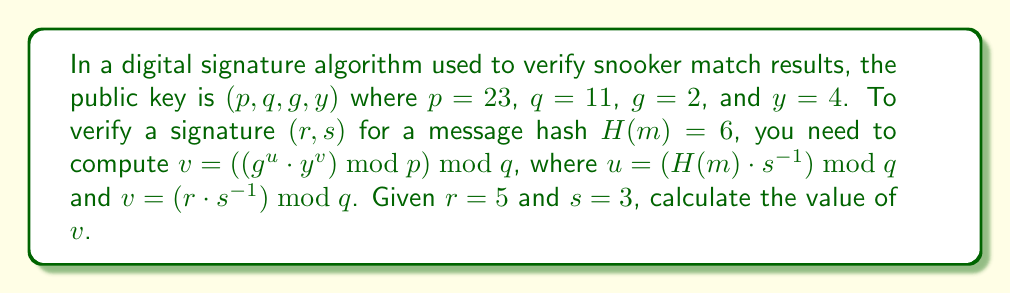Solve this math problem. Let's break this down step-by-step:

1) First, we need to calculate $s^{-1} \bmod q$:
   $s^{-1} \equiv 3^{-1} \equiv 4 \pmod{11}$ (since $3 \cdot 4 \equiv 1 \pmod{11}$)

2) Now we can calculate $u$:
   $u = (H(m) \cdot s^{-1}) \bmod q = (6 \cdot 4) \bmod 11 = 24 \bmod 11 = 2$

3) And $v$:
   $v = (r \cdot s^{-1}) \bmod q = (5 \cdot 4) \bmod 11 = 20 \bmod 11 = 9$

4) Now we need to compute $g^u \bmod p$:
   $g^u \bmod p = 2^2 \bmod 23 = 4$

5) And $y^v \bmod p$:
   $y^v \bmod p = 4^9 \bmod 23$
   We can use the square-and-multiply method:
   $4^1 \equiv 4 \pmod{23}$
   $4^2 \equiv 16 \pmod{23}$
   $4^4 \equiv 16^2 \equiv 3 \pmod{23}$
   $4^8 \equiv 3^2 \equiv 9 \pmod{23}$
   $4^9 \equiv 4^8 \cdot 4^1 \equiv 9 \cdot 4 \equiv 13 \pmod{23}$

6) Now we multiply these results:
   $(g^u \cdot y^v) \bmod p = (4 \cdot 13) \bmod 23 = 52 \bmod 23 = 6$

7) Finally, we take this result modulo $q$:
   $6 \bmod 11 = 6$

Therefore, $v = 6$.
Answer: $6$ 